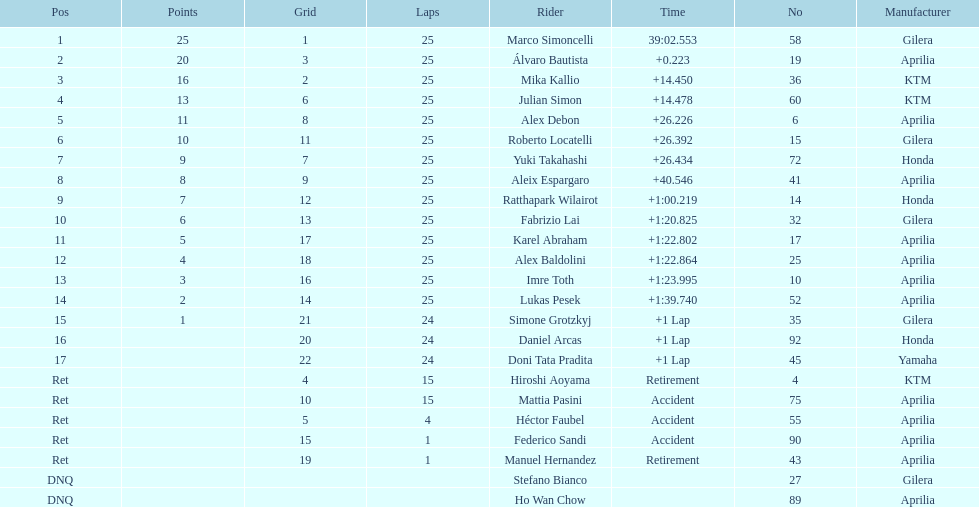The next rider from italy aside from winner marco simoncelli was Roberto Locatelli. 